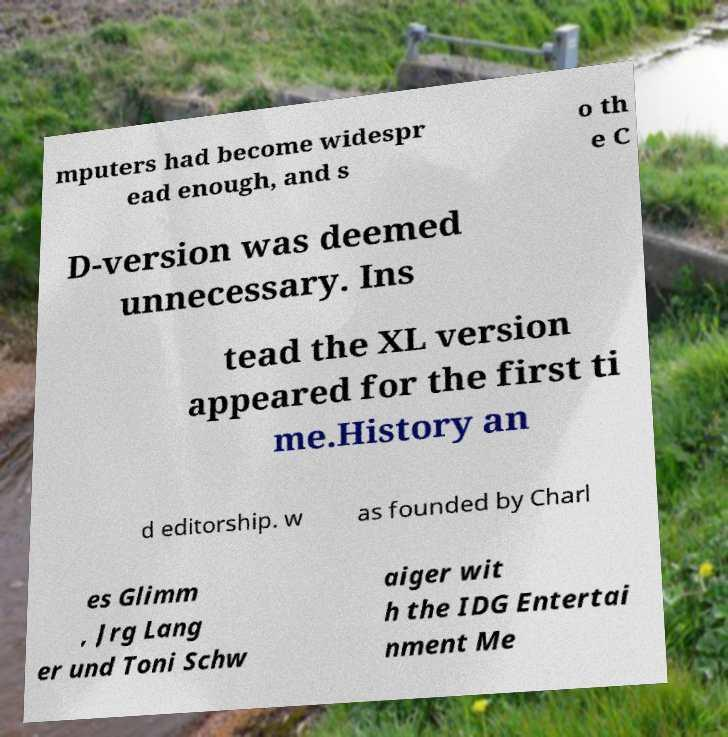There's text embedded in this image that I need extracted. Can you transcribe it verbatim? mputers had become widespr ead enough, and s o th e C D-version was deemed unnecessary. Ins tead the XL version appeared for the first ti me.History an d editorship. w as founded by Charl es Glimm , Jrg Lang er und Toni Schw aiger wit h the IDG Entertai nment Me 